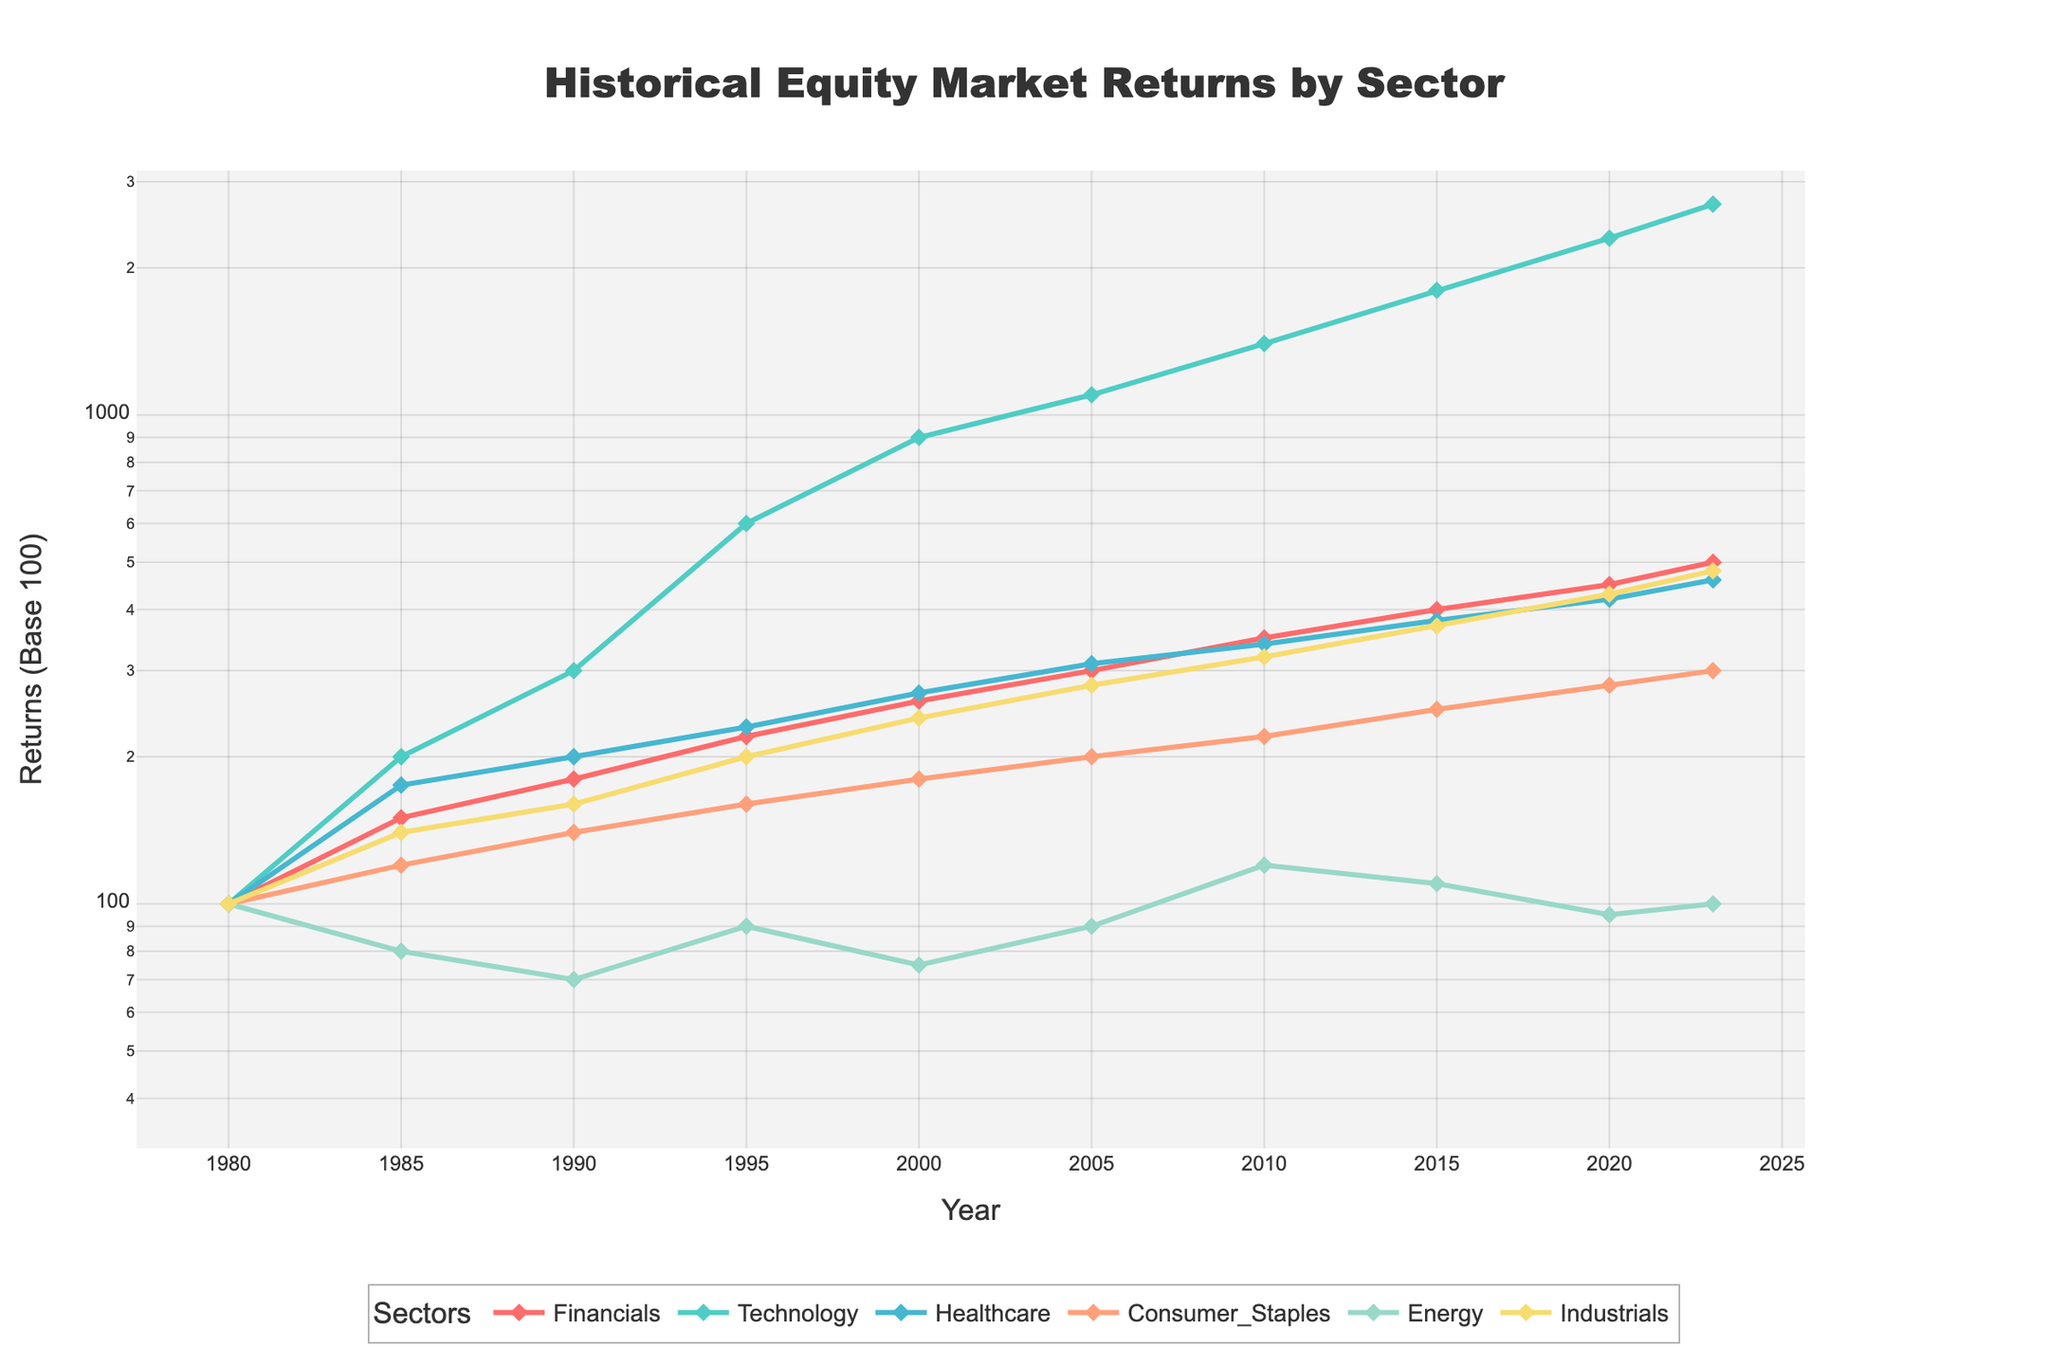What's the title of the figure? The title is located at the top of the figure. It tells us what the figure is about.
Answer: Historical Equity Market Returns by Sector Which sector had the highest return in 2023? Locate the data points for 2023 and find the sector with the highest value on the y-axis.
Answer: Technology How did the Healthcare sector's returns change from 1980 to 2023? Check the data points for Healthcare in 1980 and 2023 and compare the values.
Answer: Increased from 100 to 460 Which sector had lower returns in 2020 compared to 2015? Compare the data points for each sector in 2015 and 2020, identifying any sectors where the value in 2020 is lower than in 2015.
Answer: Energy What is the average return of the Financials sector from 1980 to 2023? Add up the returns of the Financials sector at each time point and divide by the number of time points.
Answer: 310 Does the Consumer Staples sector show consistent growth over time? Check the trend of Consumer Staples sector from 1980 to 2023 and note if it consistently increases without major drops.
Answer: Yes In which years did the Financials sector reach a return of 400? Locate the data points of the Financials sector and find the years where its value is 400.
Answer: 2015 Compare the growth rates of Technology and Energy sectors from 1980 to 2023. Calculate the rate of change over the period for both sectors and compare the two growth rates.
Answer: Technology had a much higher growth rate than Energy How does the log scale impact the perception of returns over time? Evaluate how the use of a logarithmic scale affects the visual representation of changes and growth over time. Log scales can make exponential growth appear linear and small changes in early years more noticeable.
Answer: It makes exponential growth appear linear and early changes more noticeable 